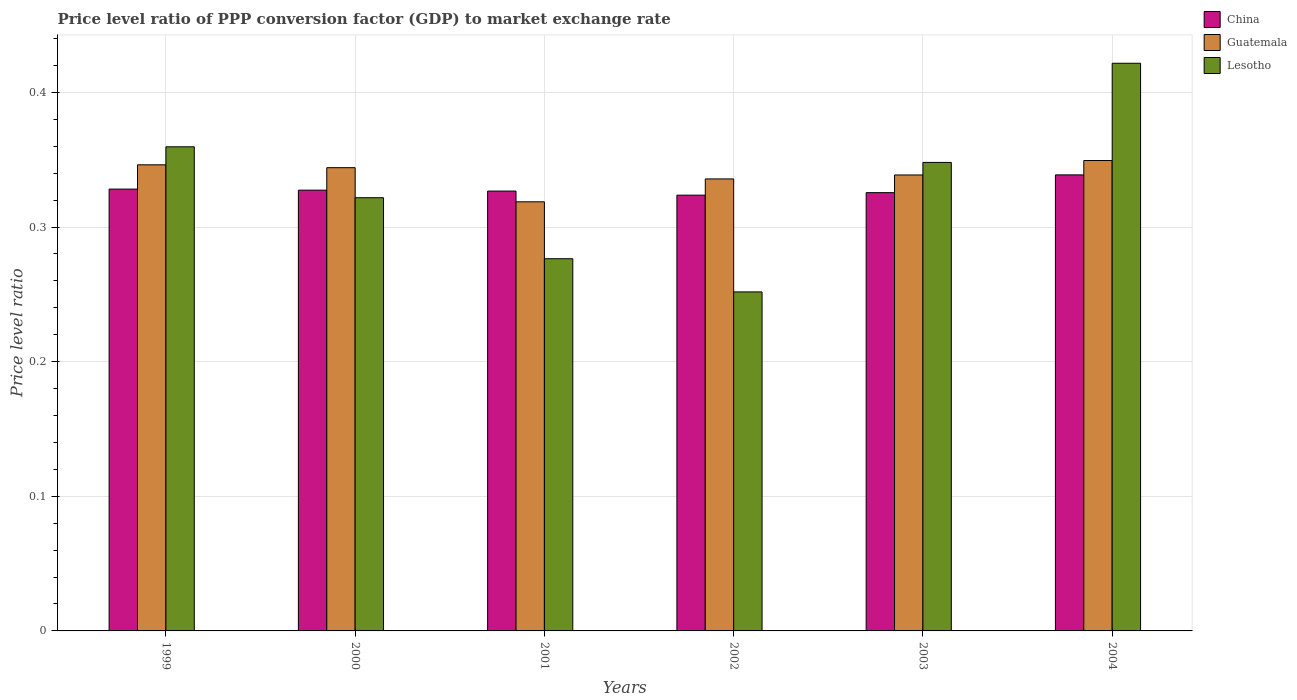Are the number of bars per tick equal to the number of legend labels?
Give a very brief answer. Yes. What is the label of the 3rd group of bars from the left?
Offer a very short reply. 2001. What is the price level ratio in Lesotho in 2004?
Give a very brief answer. 0.42. Across all years, what is the maximum price level ratio in Lesotho?
Give a very brief answer. 0.42. Across all years, what is the minimum price level ratio in Guatemala?
Keep it short and to the point. 0.32. In which year was the price level ratio in China minimum?
Offer a very short reply. 2002. What is the total price level ratio in Guatemala in the graph?
Your answer should be compact. 2.03. What is the difference between the price level ratio in Guatemala in 1999 and that in 2004?
Keep it short and to the point. -0. What is the difference between the price level ratio in Lesotho in 2003 and the price level ratio in Guatemala in 2002?
Make the answer very short. 0.01. What is the average price level ratio in Guatemala per year?
Keep it short and to the point. 0.34. In the year 2004, what is the difference between the price level ratio in Guatemala and price level ratio in Lesotho?
Your answer should be very brief. -0.07. What is the ratio of the price level ratio in China in 2000 to that in 2002?
Provide a succinct answer. 1.01. Is the price level ratio in Lesotho in 1999 less than that in 2004?
Offer a very short reply. Yes. What is the difference between the highest and the second highest price level ratio in China?
Keep it short and to the point. 0.01. What is the difference between the highest and the lowest price level ratio in Guatemala?
Keep it short and to the point. 0.03. Is the sum of the price level ratio in Lesotho in 2001 and 2002 greater than the maximum price level ratio in Guatemala across all years?
Provide a short and direct response. Yes. What does the 3rd bar from the left in 2001 represents?
Provide a short and direct response. Lesotho. What does the 1st bar from the right in 1999 represents?
Offer a terse response. Lesotho. How many years are there in the graph?
Your answer should be very brief. 6. Are the values on the major ticks of Y-axis written in scientific E-notation?
Your answer should be compact. No. Does the graph contain grids?
Your response must be concise. Yes. Where does the legend appear in the graph?
Ensure brevity in your answer.  Top right. How are the legend labels stacked?
Offer a terse response. Vertical. What is the title of the graph?
Keep it short and to the point. Price level ratio of PPP conversion factor (GDP) to market exchange rate. What is the label or title of the Y-axis?
Keep it short and to the point. Price level ratio. What is the Price level ratio in China in 1999?
Your response must be concise. 0.33. What is the Price level ratio in Guatemala in 1999?
Ensure brevity in your answer.  0.35. What is the Price level ratio of Lesotho in 1999?
Ensure brevity in your answer.  0.36. What is the Price level ratio in China in 2000?
Provide a succinct answer. 0.33. What is the Price level ratio of Guatemala in 2000?
Ensure brevity in your answer.  0.34. What is the Price level ratio of Lesotho in 2000?
Provide a short and direct response. 0.32. What is the Price level ratio of China in 2001?
Keep it short and to the point. 0.33. What is the Price level ratio of Guatemala in 2001?
Give a very brief answer. 0.32. What is the Price level ratio in Lesotho in 2001?
Give a very brief answer. 0.28. What is the Price level ratio of China in 2002?
Ensure brevity in your answer.  0.32. What is the Price level ratio in Guatemala in 2002?
Keep it short and to the point. 0.34. What is the Price level ratio in Lesotho in 2002?
Your answer should be very brief. 0.25. What is the Price level ratio of China in 2003?
Provide a short and direct response. 0.33. What is the Price level ratio in Guatemala in 2003?
Provide a succinct answer. 0.34. What is the Price level ratio of Lesotho in 2003?
Your answer should be compact. 0.35. What is the Price level ratio in China in 2004?
Keep it short and to the point. 0.34. What is the Price level ratio of Guatemala in 2004?
Give a very brief answer. 0.35. What is the Price level ratio of Lesotho in 2004?
Provide a succinct answer. 0.42. Across all years, what is the maximum Price level ratio in China?
Offer a very short reply. 0.34. Across all years, what is the maximum Price level ratio of Guatemala?
Your answer should be very brief. 0.35. Across all years, what is the maximum Price level ratio in Lesotho?
Give a very brief answer. 0.42. Across all years, what is the minimum Price level ratio in China?
Your answer should be compact. 0.32. Across all years, what is the minimum Price level ratio in Guatemala?
Provide a short and direct response. 0.32. Across all years, what is the minimum Price level ratio of Lesotho?
Your response must be concise. 0.25. What is the total Price level ratio of China in the graph?
Provide a short and direct response. 1.97. What is the total Price level ratio in Guatemala in the graph?
Provide a short and direct response. 2.03. What is the total Price level ratio in Lesotho in the graph?
Give a very brief answer. 1.98. What is the difference between the Price level ratio of China in 1999 and that in 2000?
Your answer should be very brief. 0. What is the difference between the Price level ratio of Guatemala in 1999 and that in 2000?
Your answer should be very brief. 0. What is the difference between the Price level ratio in Lesotho in 1999 and that in 2000?
Your response must be concise. 0.04. What is the difference between the Price level ratio of China in 1999 and that in 2001?
Your response must be concise. 0. What is the difference between the Price level ratio in Guatemala in 1999 and that in 2001?
Your answer should be compact. 0.03. What is the difference between the Price level ratio in Lesotho in 1999 and that in 2001?
Ensure brevity in your answer.  0.08. What is the difference between the Price level ratio in China in 1999 and that in 2002?
Your answer should be very brief. 0. What is the difference between the Price level ratio in Guatemala in 1999 and that in 2002?
Make the answer very short. 0.01. What is the difference between the Price level ratio of Lesotho in 1999 and that in 2002?
Your response must be concise. 0.11. What is the difference between the Price level ratio in China in 1999 and that in 2003?
Offer a terse response. 0. What is the difference between the Price level ratio of Guatemala in 1999 and that in 2003?
Your response must be concise. 0.01. What is the difference between the Price level ratio of Lesotho in 1999 and that in 2003?
Offer a terse response. 0.01. What is the difference between the Price level ratio of China in 1999 and that in 2004?
Offer a very short reply. -0.01. What is the difference between the Price level ratio of Guatemala in 1999 and that in 2004?
Offer a terse response. -0. What is the difference between the Price level ratio of Lesotho in 1999 and that in 2004?
Ensure brevity in your answer.  -0.06. What is the difference between the Price level ratio in China in 2000 and that in 2001?
Give a very brief answer. 0. What is the difference between the Price level ratio of Guatemala in 2000 and that in 2001?
Your response must be concise. 0.03. What is the difference between the Price level ratio of Lesotho in 2000 and that in 2001?
Offer a terse response. 0.05. What is the difference between the Price level ratio of China in 2000 and that in 2002?
Provide a succinct answer. 0. What is the difference between the Price level ratio of Guatemala in 2000 and that in 2002?
Provide a succinct answer. 0.01. What is the difference between the Price level ratio in Lesotho in 2000 and that in 2002?
Ensure brevity in your answer.  0.07. What is the difference between the Price level ratio of China in 2000 and that in 2003?
Your answer should be compact. 0. What is the difference between the Price level ratio of Guatemala in 2000 and that in 2003?
Offer a very short reply. 0.01. What is the difference between the Price level ratio in Lesotho in 2000 and that in 2003?
Provide a succinct answer. -0.03. What is the difference between the Price level ratio of China in 2000 and that in 2004?
Your answer should be very brief. -0.01. What is the difference between the Price level ratio of Guatemala in 2000 and that in 2004?
Give a very brief answer. -0.01. What is the difference between the Price level ratio in Lesotho in 2000 and that in 2004?
Give a very brief answer. -0.1. What is the difference between the Price level ratio of China in 2001 and that in 2002?
Your answer should be compact. 0. What is the difference between the Price level ratio of Guatemala in 2001 and that in 2002?
Your response must be concise. -0.02. What is the difference between the Price level ratio in Lesotho in 2001 and that in 2002?
Your answer should be compact. 0.02. What is the difference between the Price level ratio of China in 2001 and that in 2003?
Provide a succinct answer. 0. What is the difference between the Price level ratio of Guatemala in 2001 and that in 2003?
Your answer should be compact. -0.02. What is the difference between the Price level ratio of Lesotho in 2001 and that in 2003?
Offer a terse response. -0.07. What is the difference between the Price level ratio of China in 2001 and that in 2004?
Make the answer very short. -0.01. What is the difference between the Price level ratio of Guatemala in 2001 and that in 2004?
Offer a terse response. -0.03. What is the difference between the Price level ratio in Lesotho in 2001 and that in 2004?
Make the answer very short. -0.15. What is the difference between the Price level ratio of China in 2002 and that in 2003?
Offer a very short reply. -0. What is the difference between the Price level ratio in Guatemala in 2002 and that in 2003?
Provide a short and direct response. -0. What is the difference between the Price level ratio of Lesotho in 2002 and that in 2003?
Make the answer very short. -0.1. What is the difference between the Price level ratio of China in 2002 and that in 2004?
Keep it short and to the point. -0.02. What is the difference between the Price level ratio of Guatemala in 2002 and that in 2004?
Ensure brevity in your answer.  -0.01. What is the difference between the Price level ratio in Lesotho in 2002 and that in 2004?
Ensure brevity in your answer.  -0.17. What is the difference between the Price level ratio in China in 2003 and that in 2004?
Keep it short and to the point. -0.01. What is the difference between the Price level ratio of Guatemala in 2003 and that in 2004?
Make the answer very short. -0.01. What is the difference between the Price level ratio of Lesotho in 2003 and that in 2004?
Ensure brevity in your answer.  -0.07. What is the difference between the Price level ratio of China in 1999 and the Price level ratio of Guatemala in 2000?
Offer a very short reply. -0.02. What is the difference between the Price level ratio in China in 1999 and the Price level ratio in Lesotho in 2000?
Your answer should be compact. 0.01. What is the difference between the Price level ratio of Guatemala in 1999 and the Price level ratio of Lesotho in 2000?
Your answer should be compact. 0.02. What is the difference between the Price level ratio of China in 1999 and the Price level ratio of Guatemala in 2001?
Provide a succinct answer. 0.01. What is the difference between the Price level ratio in China in 1999 and the Price level ratio in Lesotho in 2001?
Offer a terse response. 0.05. What is the difference between the Price level ratio in Guatemala in 1999 and the Price level ratio in Lesotho in 2001?
Offer a terse response. 0.07. What is the difference between the Price level ratio of China in 1999 and the Price level ratio of Guatemala in 2002?
Give a very brief answer. -0.01. What is the difference between the Price level ratio in China in 1999 and the Price level ratio in Lesotho in 2002?
Offer a very short reply. 0.08. What is the difference between the Price level ratio in Guatemala in 1999 and the Price level ratio in Lesotho in 2002?
Ensure brevity in your answer.  0.09. What is the difference between the Price level ratio of China in 1999 and the Price level ratio of Guatemala in 2003?
Make the answer very short. -0.01. What is the difference between the Price level ratio of China in 1999 and the Price level ratio of Lesotho in 2003?
Give a very brief answer. -0.02. What is the difference between the Price level ratio of Guatemala in 1999 and the Price level ratio of Lesotho in 2003?
Offer a very short reply. -0. What is the difference between the Price level ratio in China in 1999 and the Price level ratio in Guatemala in 2004?
Your answer should be very brief. -0.02. What is the difference between the Price level ratio of China in 1999 and the Price level ratio of Lesotho in 2004?
Your response must be concise. -0.09. What is the difference between the Price level ratio in Guatemala in 1999 and the Price level ratio in Lesotho in 2004?
Ensure brevity in your answer.  -0.08. What is the difference between the Price level ratio of China in 2000 and the Price level ratio of Guatemala in 2001?
Offer a very short reply. 0.01. What is the difference between the Price level ratio in China in 2000 and the Price level ratio in Lesotho in 2001?
Provide a succinct answer. 0.05. What is the difference between the Price level ratio in Guatemala in 2000 and the Price level ratio in Lesotho in 2001?
Provide a short and direct response. 0.07. What is the difference between the Price level ratio in China in 2000 and the Price level ratio in Guatemala in 2002?
Offer a terse response. -0.01. What is the difference between the Price level ratio in China in 2000 and the Price level ratio in Lesotho in 2002?
Provide a succinct answer. 0.08. What is the difference between the Price level ratio in Guatemala in 2000 and the Price level ratio in Lesotho in 2002?
Provide a short and direct response. 0.09. What is the difference between the Price level ratio in China in 2000 and the Price level ratio in Guatemala in 2003?
Ensure brevity in your answer.  -0.01. What is the difference between the Price level ratio in China in 2000 and the Price level ratio in Lesotho in 2003?
Keep it short and to the point. -0.02. What is the difference between the Price level ratio of Guatemala in 2000 and the Price level ratio of Lesotho in 2003?
Offer a terse response. -0. What is the difference between the Price level ratio of China in 2000 and the Price level ratio of Guatemala in 2004?
Your answer should be compact. -0.02. What is the difference between the Price level ratio in China in 2000 and the Price level ratio in Lesotho in 2004?
Ensure brevity in your answer.  -0.09. What is the difference between the Price level ratio of Guatemala in 2000 and the Price level ratio of Lesotho in 2004?
Your answer should be compact. -0.08. What is the difference between the Price level ratio in China in 2001 and the Price level ratio in Guatemala in 2002?
Ensure brevity in your answer.  -0.01. What is the difference between the Price level ratio of China in 2001 and the Price level ratio of Lesotho in 2002?
Your response must be concise. 0.07. What is the difference between the Price level ratio of Guatemala in 2001 and the Price level ratio of Lesotho in 2002?
Offer a terse response. 0.07. What is the difference between the Price level ratio of China in 2001 and the Price level ratio of Guatemala in 2003?
Give a very brief answer. -0.01. What is the difference between the Price level ratio of China in 2001 and the Price level ratio of Lesotho in 2003?
Your answer should be very brief. -0.02. What is the difference between the Price level ratio in Guatemala in 2001 and the Price level ratio in Lesotho in 2003?
Give a very brief answer. -0.03. What is the difference between the Price level ratio in China in 2001 and the Price level ratio in Guatemala in 2004?
Ensure brevity in your answer.  -0.02. What is the difference between the Price level ratio in China in 2001 and the Price level ratio in Lesotho in 2004?
Give a very brief answer. -0.09. What is the difference between the Price level ratio of Guatemala in 2001 and the Price level ratio of Lesotho in 2004?
Keep it short and to the point. -0.1. What is the difference between the Price level ratio in China in 2002 and the Price level ratio in Guatemala in 2003?
Your answer should be very brief. -0.01. What is the difference between the Price level ratio in China in 2002 and the Price level ratio in Lesotho in 2003?
Give a very brief answer. -0.02. What is the difference between the Price level ratio in Guatemala in 2002 and the Price level ratio in Lesotho in 2003?
Offer a terse response. -0.01. What is the difference between the Price level ratio in China in 2002 and the Price level ratio in Guatemala in 2004?
Keep it short and to the point. -0.03. What is the difference between the Price level ratio of China in 2002 and the Price level ratio of Lesotho in 2004?
Keep it short and to the point. -0.1. What is the difference between the Price level ratio of Guatemala in 2002 and the Price level ratio of Lesotho in 2004?
Offer a terse response. -0.09. What is the difference between the Price level ratio of China in 2003 and the Price level ratio of Guatemala in 2004?
Make the answer very short. -0.02. What is the difference between the Price level ratio of China in 2003 and the Price level ratio of Lesotho in 2004?
Provide a short and direct response. -0.1. What is the difference between the Price level ratio of Guatemala in 2003 and the Price level ratio of Lesotho in 2004?
Offer a terse response. -0.08. What is the average Price level ratio in China per year?
Offer a terse response. 0.33. What is the average Price level ratio in Guatemala per year?
Offer a very short reply. 0.34. What is the average Price level ratio in Lesotho per year?
Provide a succinct answer. 0.33. In the year 1999, what is the difference between the Price level ratio of China and Price level ratio of Guatemala?
Offer a terse response. -0.02. In the year 1999, what is the difference between the Price level ratio in China and Price level ratio in Lesotho?
Keep it short and to the point. -0.03. In the year 1999, what is the difference between the Price level ratio of Guatemala and Price level ratio of Lesotho?
Offer a very short reply. -0.01. In the year 2000, what is the difference between the Price level ratio in China and Price level ratio in Guatemala?
Offer a terse response. -0.02. In the year 2000, what is the difference between the Price level ratio in China and Price level ratio in Lesotho?
Provide a succinct answer. 0.01. In the year 2000, what is the difference between the Price level ratio of Guatemala and Price level ratio of Lesotho?
Your answer should be compact. 0.02. In the year 2001, what is the difference between the Price level ratio of China and Price level ratio of Guatemala?
Provide a succinct answer. 0.01. In the year 2001, what is the difference between the Price level ratio of China and Price level ratio of Lesotho?
Make the answer very short. 0.05. In the year 2001, what is the difference between the Price level ratio in Guatemala and Price level ratio in Lesotho?
Provide a succinct answer. 0.04. In the year 2002, what is the difference between the Price level ratio of China and Price level ratio of Guatemala?
Provide a succinct answer. -0.01. In the year 2002, what is the difference between the Price level ratio in China and Price level ratio in Lesotho?
Your answer should be compact. 0.07. In the year 2002, what is the difference between the Price level ratio in Guatemala and Price level ratio in Lesotho?
Your answer should be very brief. 0.08. In the year 2003, what is the difference between the Price level ratio of China and Price level ratio of Guatemala?
Provide a succinct answer. -0.01. In the year 2003, what is the difference between the Price level ratio in China and Price level ratio in Lesotho?
Provide a short and direct response. -0.02. In the year 2003, what is the difference between the Price level ratio in Guatemala and Price level ratio in Lesotho?
Offer a very short reply. -0.01. In the year 2004, what is the difference between the Price level ratio in China and Price level ratio in Guatemala?
Keep it short and to the point. -0.01. In the year 2004, what is the difference between the Price level ratio in China and Price level ratio in Lesotho?
Your answer should be very brief. -0.08. In the year 2004, what is the difference between the Price level ratio in Guatemala and Price level ratio in Lesotho?
Ensure brevity in your answer.  -0.07. What is the ratio of the Price level ratio of Guatemala in 1999 to that in 2000?
Provide a succinct answer. 1.01. What is the ratio of the Price level ratio in Lesotho in 1999 to that in 2000?
Your answer should be compact. 1.12. What is the ratio of the Price level ratio of China in 1999 to that in 2001?
Your answer should be compact. 1. What is the ratio of the Price level ratio of Guatemala in 1999 to that in 2001?
Provide a succinct answer. 1.09. What is the ratio of the Price level ratio in Lesotho in 1999 to that in 2001?
Make the answer very short. 1.3. What is the ratio of the Price level ratio in China in 1999 to that in 2002?
Your response must be concise. 1.01. What is the ratio of the Price level ratio of Guatemala in 1999 to that in 2002?
Provide a succinct answer. 1.03. What is the ratio of the Price level ratio in Lesotho in 1999 to that in 2002?
Provide a short and direct response. 1.43. What is the ratio of the Price level ratio in Guatemala in 1999 to that in 2003?
Provide a short and direct response. 1.02. What is the ratio of the Price level ratio of Lesotho in 1999 to that in 2003?
Your answer should be compact. 1.03. What is the ratio of the Price level ratio in China in 1999 to that in 2004?
Offer a terse response. 0.97. What is the ratio of the Price level ratio of Guatemala in 1999 to that in 2004?
Provide a succinct answer. 0.99. What is the ratio of the Price level ratio in Lesotho in 1999 to that in 2004?
Offer a terse response. 0.85. What is the ratio of the Price level ratio of Guatemala in 2000 to that in 2001?
Provide a succinct answer. 1.08. What is the ratio of the Price level ratio of Lesotho in 2000 to that in 2001?
Make the answer very short. 1.16. What is the ratio of the Price level ratio in China in 2000 to that in 2002?
Offer a terse response. 1.01. What is the ratio of the Price level ratio in Guatemala in 2000 to that in 2002?
Provide a succinct answer. 1.02. What is the ratio of the Price level ratio of Lesotho in 2000 to that in 2002?
Give a very brief answer. 1.28. What is the ratio of the Price level ratio in Lesotho in 2000 to that in 2003?
Your answer should be very brief. 0.92. What is the ratio of the Price level ratio of China in 2000 to that in 2004?
Give a very brief answer. 0.97. What is the ratio of the Price level ratio of Lesotho in 2000 to that in 2004?
Provide a short and direct response. 0.76. What is the ratio of the Price level ratio in China in 2001 to that in 2002?
Ensure brevity in your answer.  1.01. What is the ratio of the Price level ratio of Guatemala in 2001 to that in 2002?
Keep it short and to the point. 0.95. What is the ratio of the Price level ratio in Lesotho in 2001 to that in 2002?
Make the answer very short. 1.1. What is the ratio of the Price level ratio in China in 2001 to that in 2003?
Offer a very short reply. 1. What is the ratio of the Price level ratio in Guatemala in 2001 to that in 2003?
Your answer should be compact. 0.94. What is the ratio of the Price level ratio of Lesotho in 2001 to that in 2003?
Give a very brief answer. 0.79. What is the ratio of the Price level ratio in China in 2001 to that in 2004?
Your response must be concise. 0.96. What is the ratio of the Price level ratio in Guatemala in 2001 to that in 2004?
Provide a short and direct response. 0.91. What is the ratio of the Price level ratio in Lesotho in 2001 to that in 2004?
Offer a terse response. 0.66. What is the ratio of the Price level ratio in China in 2002 to that in 2003?
Ensure brevity in your answer.  0.99. What is the ratio of the Price level ratio in Guatemala in 2002 to that in 2003?
Your answer should be compact. 0.99. What is the ratio of the Price level ratio in Lesotho in 2002 to that in 2003?
Offer a very short reply. 0.72. What is the ratio of the Price level ratio in China in 2002 to that in 2004?
Your response must be concise. 0.96. What is the ratio of the Price level ratio of Guatemala in 2002 to that in 2004?
Offer a very short reply. 0.96. What is the ratio of the Price level ratio in Lesotho in 2002 to that in 2004?
Make the answer very short. 0.6. What is the ratio of the Price level ratio in Guatemala in 2003 to that in 2004?
Offer a terse response. 0.97. What is the ratio of the Price level ratio of Lesotho in 2003 to that in 2004?
Offer a terse response. 0.83. What is the difference between the highest and the second highest Price level ratio of China?
Make the answer very short. 0.01. What is the difference between the highest and the second highest Price level ratio of Guatemala?
Provide a short and direct response. 0. What is the difference between the highest and the second highest Price level ratio in Lesotho?
Your answer should be compact. 0.06. What is the difference between the highest and the lowest Price level ratio of China?
Offer a very short reply. 0.02. What is the difference between the highest and the lowest Price level ratio in Guatemala?
Give a very brief answer. 0.03. What is the difference between the highest and the lowest Price level ratio in Lesotho?
Your response must be concise. 0.17. 